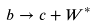<formula> <loc_0><loc_0><loc_500><loc_500>b \rightarrow c + W ^ { * }</formula> 